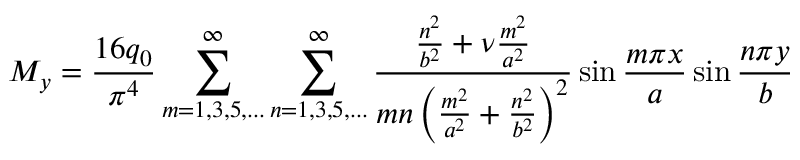<formula> <loc_0><loc_0><loc_500><loc_500>M _ { y } = { \frac { 1 6 q _ { 0 } } { \pi ^ { 4 } } } \sum _ { m = 1 , 3 , 5 , \dots } ^ { \infty } \sum _ { n = 1 , 3 , 5 , \dots } ^ { \infty } { \frac { { \frac { n ^ { 2 } } { b ^ { 2 } } } + \nu { \frac { m ^ { 2 } } { a ^ { 2 } } } } { m n \left ( { \frac { m ^ { 2 } } { a ^ { 2 } } } + { \frac { n ^ { 2 } } { b ^ { 2 } } } \right ) ^ { 2 } } } \sin { \frac { m \pi x } { a } } \sin { \frac { n \pi y } { b } }</formula> 